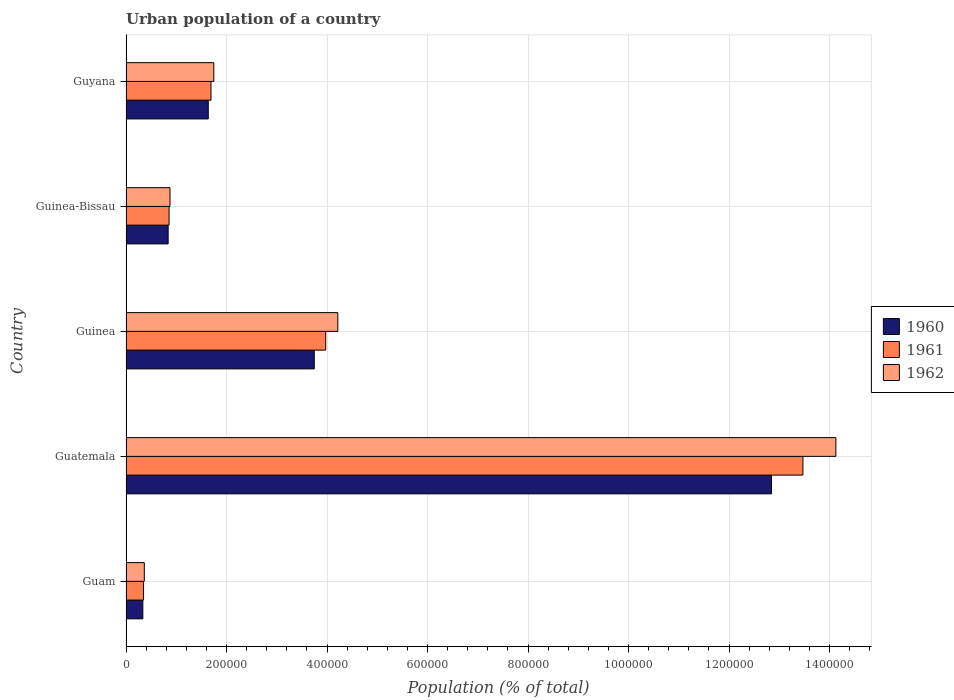How many groups of bars are there?
Offer a terse response. 5. Are the number of bars per tick equal to the number of legend labels?
Give a very brief answer. Yes. How many bars are there on the 3rd tick from the bottom?
Offer a terse response. 3. What is the label of the 5th group of bars from the top?
Ensure brevity in your answer.  Guam. What is the urban population in 1962 in Guam?
Offer a terse response. 3.64e+04. Across all countries, what is the maximum urban population in 1961?
Offer a terse response. 1.35e+06. Across all countries, what is the minimum urban population in 1962?
Keep it short and to the point. 3.64e+04. In which country was the urban population in 1960 maximum?
Provide a succinct answer. Guatemala. In which country was the urban population in 1960 minimum?
Make the answer very short. Guam. What is the total urban population in 1961 in the graph?
Your answer should be very brief. 2.03e+06. What is the difference between the urban population in 1961 in Guatemala and that in Guinea-Bissau?
Ensure brevity in your answer.  1.26e+06. What is the difference between the urban population in 1961 in Guam and the urban population in 1962 in Guinea-Bissau?
Keep it short and to the point. -5.27e+04. What is the average urban population in 1960 per country?
Keep it short and to the point. 3.88e+05. What is the difference between the urban population in 1960 and urban population in 1961 in Guatemala?
Give a very brief answer. -6.25e+04. What is the ratio of the urban population in 1961 in Guatemala to that in Guinea?
Make the answer very short. 3.39. Is the urban population in 1961 in Guam less than that in Guinea-Bissau?
Offer a very short reply. Yes. Is the difference between the urban population in 1960 in Guam and Guinea-Bissau greater than the difference between the urban population in 1961 in Guam and Guinea-Bissau?
Your answer should be very brief. Yes. What is the difference between the highest and the second highest urban population in 1961?
Your answer should be very brief. 9.50e+05. What is the difference between the highest and the lowest urban population in 1960?
Your answer should be very brief. 1.25e+06. In how many countries, is the urban population in 1960 greater than the average urban population in 1960 taken over all countries?
Offer a very short reply. 1. What does the 1st bar from the top in Guam represents?
Provide a succinct answer. 1962. How many bars are there?
Keep it short and to the point. 15. How many countries are there in the graph?
Offer a terse response. 5. What is the difference between two consecutive major ticks on the X-axis?
Make the answer very short. 2.00e+05. Does the graph contain any zero values?
Keep it short and to the point. No. How many legend labels are there?
Make the answer very short. 3. How are the legend labels stacked?
Provide a short and direct response. Vertical. What is the title of the graph?
Provide a short and direct response. Urban population of a country. What is the label or title of the X-axis?
Provide a succinct answer. Population (% of total). What is the Population (% of total) of 1960 in Guam?
Provide a succinct answer. 3.35e+04. What is the Population (% of total) of 1961 in Guam?
Provide a succinct answer. 3.49e+04. What is the Population (% of total) of 1962 in Guam?
Give a very brief answer. 3.64e+04. What is the Population (% of total) of 1960 in Guatemala?
Offer a very short reply. 1.28e+06. What is the Population (% of total) of 1961 in Guatemala?
Your response must be concise. 1.35e+06. What is the Population (% of total) of 1962 in Guatemala?
Offer a terse response. 1.41e+06. What is the Population (% of total) of 1960 in Guinea?
Make the answer very short. 3.75e+05. What is the Population (% of total) of 1961 in Guinea?
Offer a very short reply. 3.97e+05. What is the Population (% of total) in 1962 in Guinea?
Keep it short and to the point. 4.21e+05. What is the Population (% of total) of 1960 in Guinea-Bissau?
Your response must be concise. 8.38e+04. What is the Population (% of total) of 1961 in Guinea-Bissau?
Offer a terse response. 8.57e+04. What is the Population (% of total) in 1962 in Guinea-Bissau?
Your answer should be very brief. 8.75e+04. What is the Population (% of total) of 1960 in Guyana?
Offer a terse response. 1.64e+05. What is the Population (% of total) in 1961 in Guyana?
Make the answer very short. 1.69e+05. What is the Population (% of total) in 1962 in Guyana?
Keep it short and to the point. 1.75e+05. Across all countries, what is the maximum Population (% of total) in 1960?
Ensure brevity in your answer.  1.28e+06. Across all countries, what is the maximum Population (% of total) in 1961?
Ensure brevity in your answer.  1.35e+06. Across all countries, what is the maximum Population (% of total) of 1962?
Your answer should be very brief. 1.41e+06. Across all countries, what is the minimum Population (% of total) of 1960?
Your answer should be compact. 3.35e+04. Across all countries, what is the minimum Population (% of total) in 1961?
Your answer should be very brief. 3.49e+04. Across all countries, what is the minimum Population (% of total) in 1962?
Offer a very short reply. 3.64e+04. What is the total Population (% of total) in 1960 in the graph?
Your answer should be compact. 1.94e+06. What is the total Population (% of total) in 1961 in the graph?
Your response must be concise. 2.03e+06. What is the total Population (% of total) of 1962 in the graph?
Ensure brevity in your answer.  2.13e+06. What is the difference between the Population (% of total) of 1960 in Guam and that in Guatemala?
Make the answer very short. -1.25e+06. What is the difference between the Population (% of total) of 1961 in Guam and that in Guatemala?
Provide a succinct answer. -1.31e+06. What is the difference between the Population (% of total) in 1962 in Guam and that in Guatemala?
Offer a terse response. -1.38e+06. What is the difference between the Population (% of total) of 1960 in Guam and that in Guinea?
Your answer should be very brief. -3.41e+05. What is the difference between the Population (% of total) of 1961 in Guam and that in Guinea?
Make the answer very short. -3.63e+05. What is the difference between the Population (% of total) in 1962 in Guam and that in Guinea?
Give a very brief answer. -3.85e+05. What is the difference between the Population (% of total) in 1960 in Guam and that in Guinea-Bissau?
Offer a very short reply. -5.04e+04. What is the difference between the Population (% of total) in 1961 in Guam and that in Guinea-Bissau?
Provide a short and direct response. -5.08e+04. What is the difference between the Population (% of total) of 1962 in Guam and that in Guinea-Bissau?
Your response must be concise. -5.11e+04. What is the difference between the Population (% of total) in 1960 in Guam and that in Guyana?
Give a very brief answer. -1.30e+05. What is the difference between the Population (% of total) of 1961 in Guam and that in Guyana?
Provide a short and direct response. -1.34e+05. What is the difference between the Population (% of total) in 1962 in Guam and that in Guyana?
Your answer should be compact. -1.38e+05. What is the difference between the Population (% of total) of 1960 in Guatemala and that in Guinea?
Keep it short and to the point. 9.10e+05. What is the difference between the Population (% of total) in 1961 in Guatemala and that in Guinea?
Your response must be concise. 9.50e+05. What is the difference between the Population (% of total) of 1962 in Guatemala and that in Guinea?
Offer a very short reply. 9.91e+05. What is the difference between the Population (% of total) of 1960 in Guatemala and that in Guinea-Bissau?
Offer a very short reply. 1.20e+06. What is the difference between the Population (% of total) of 1961 in Guatemala and that in Guinea-Bissau?
Give a very brief answer. 1.26e+06. What is the difference between the Population (% of total) of 1962 in Guatemala and that in Guinea-Bissau?
Ensure brevity in your answer.  1.33e+06. What is the difference between the Population (% of total) in 1960 in Guatemala and that in Guyana?
Keep it short and to the point. 1.12e+06. What is the difference between the Population (% of total) of 1961 in Guatemala and that in Guyana?
Make the answer very short. 1.18e+06. What is the difference between the Population (% of total) in 1962 in Guatemala and that in Guyana?
Give a very brief answer. 1.24e+06. What is the difference between the Population (% of total) in 1960 in Guinea and that in Guinea-Bissau?
Provide a succinct answer. 2.91e+05. What is the difference between the Population (% of total) in 1961 in Guinea and that in Guinea-Bissau?
Your response must be concise. 3.12e+05. What is the difference between the Population (% of total) in 1962 in Guinea and that in Guinea-Bissau?
Provide a short and direct response. 3.34e+05. What is the difference between the Population (% of total) of 1960 in Guinea and that in Guyana?
Your answer should be compact. 2.11e+05. What is the difference between the Population (% of total) in 1961 in Guinea and that in Guyana?
Make the answer very short. 2.28e+05. What is the difference between the Population (% of total) in 1962 in Guinea and that in Guyana?
Offer a terse response. 2.47e+05. What is the difference between the Population (% of total) in 1960 in Guinea-Bissau and that in Guyana?
Give a very brief answer. -7.98e+04. What is the difference between the Population (% of total) of 1961 in Guinea-Bissau and that in Guyana?
Make the answer very short. -8.34e+04. What is the difference between the Population (% of total) of 1962 in Guinea-Bissau and that in Guyana?
Your response must be concise. -8.72e+04. What is the difference between the Population (% of total) in 1960 in Guam and the Population (% of total) in 1961 in Guatemala?
Offer a terse response. -1.31e+06. What is the difference between the Population (% of total) of 1960 in Guam and the Population (% of total) of 1962 in Guatemala?
Your response must be concise. -1.38e+06. What is the difference between the Population (% of total) of 1961 in Guam and the Population (% of total) of 1962 in Guatemala?
Provide a short and direct response. -1.38e+06. What is the difference between the Population (% of total) in 1960 in Guam and the Population (% of total) in 1961 in Guinea?
Your response must be concise. -3.64e+05. What is the difference between the Population (% of total) of 1960 in Guam and the Population (% of total) of 1962 in Guinea?
Provide a short and direct response. -3.88e+05. What is the difference between the Population (% of total) of 1961 in Guam and the Population (% of total) of 1962 in Guinea?
Ensure brevity in your answer.  -3.87e+05. What is the difference between the Population (% of total) of 1960 in Guam and the Population (% of total) of 1961 in Guinea-Bissau?
Offer a very short reply. -5.22e+04. What is the difference between the Population (% of total) in 1960 in Guam and the Population (% of total) in 1962 in Guinea-Bissau?
Your answer should be compact. -5.41e+04. What is the difference between the Population (% of total) of 1961 in Guam and the Population (% of total) of 1962 in Guinea-Bissau?
Your answer should be compact. -5.27e+04. What is the difference between the Population (% of total) of 1960 in Guam and the Population (% of total) of 1961 in Guyana?
Your answer should be very brief. -1.36e+05. What is the difference between the Population (% of total) in 1960 in Guam and the Population (% of total) in 1962 in Guyana?
Your answer should be very brief. -1.41e+05. What is the difference between the Population (% of total) of 1961 in Guam and the Population (% of total) of 1962 in Guyana?
Provide a short and direct response. -1.40e+05. What is the difference between the Population (% of total) in 1960 in Guatemala and the Population (% of total) in 1961 in Guinea?
Your response must be concise. 8.87e+05. What is the difference between the Population (% of total) in 1960 in Guatemala and the Population (% of total) in 1962 in Guinea?
Ensure brevity in your answer.  8.63e+05. What is the difference between the Population (% of total) in 1961 in Guatemala and the Population (% of total) in 1962 in Guinea?
Give a very brief answer. 9.26e+05. What is the difference between the Population (% of total) in 1960 in Guatemala and the Population (% of total) in 1961 in Guinea-Bissau?
Give a very brief answer. 1.20e+06. What is the difference between the Population (% of total) in 1960 in Guatemala and the Population (% of total) in 1962 in Guinea-Bissau?
Offer a very short reply. 1.20e+06. What is the difference between the Population (% of total) in 1961 in Guatemala and the Population (% of total) in 1962 in Guinea-Bissau?
Provide a succinct answer. 1.26e+06. What is the difference between the Population (% of total) in 1960 in Guatemala and the Population (% of total) in 1961 in Guyana?
Give a very brief answer. 1.12e+06. What is the difference between the Population (% of total) of 1960 in Guatemala and the Population (% of total) of 1962 in Guyana?
Your answer should be compact. 1.11e+06. What is the difference between the Population (% of total) in 1961 in Guatemala and the Population (% of total) in 1962 in Guyana?
Offer a very short reply. 1.17e+06. What is the difference between the Population (% of total) of 1960 in Guinea and the Population (% of total) of 1961 in Guinea-Bissau?
Make the answer very short. 2.89e+05. What is the difference between the Population (% of total) in 1960 in Guinea and the Population (% of total) in 1962 in Guinea-Bissau?
Keep it short and to the point. 2.87e+05. What is the difference between the Population (% of total) of 1961 in Guinea and the Population (% of total) of 1962 in Guinea-Bissau?
Your answer should be compact. 3.10e+05. What is the difference between the Population (% of total) in 1960 in Guinea and the Population (% of total) in 1961 in Guyana?
Offer a very short reply. 2.06e+05. What is the difference between the Population (% of total) in 1960 in Guinea and the Population (% of total) in 1962 in Guyana?
Give a very brief answer. 2.00e+05. What is the difference between the Population (% of total) in 1961 in Guinea and the Population (% of total) in 1962 in Guyana?
Provide a succinct answer. 2.23e+05. What is the difference between the Population (% of total) in 1960 in Guinea-Bissau and the Population (% of total) in 1961 in Guyana?
Offer a terse response. -8.52e+04. What is the difference between the Population (% of total) in 1960 in Guinea-Bissau and the Population (% of total) in 1962 in Guyana?
Offer a very short reply. -9.09e+04. What is the difference between the Population (% of total) of 1961 in Guinea-Bissau and the Population (% of total) of 1962 in Guyana?
Keep it short and to the point. -8.90e+04. What is the average Population (% of total) in 1960 per country?
Keep it short and to the point. 3.88e+05. What is the average Population (% of total) of 1961 per country?
Provide a short and direct response. 4.07e+05. What is the average Population (% of total) in 1962 per country?
Your answer should be very brief. 4.27e+05. What is the difference between the Population (% of total) of 1960 and Population (% of total) of 1961 in Guam?
Make the answer very short. -1405. What is the difference between the Population (% of total) in 1960 and Population (% of total) in 1962 in Guam?
Ensure brevity in your answer.  -2945. What is the difference between the Population (% of total) in 1961 and Population (% of total) in 1962 in Guam?
Ensure brevity in your answer.  -1540. What is the difference between the Population (% of total) of 1960 and Population (% of total) of 1961 in Guatemala?
Give a very brief answer. -6.25e+04. What is the difference between the Population (% of total) in 1960 and Population (% of total) in 1962 in Guatemala?
Provide a succinct answer. -1.28e+05. What is the difference between the Population (% of total) of 1961 and Population (% of total) of 1962 in Guatemala?
Your answer should be very brief. -6.56e+04. What is the difference between the Population (% of total) in 1960 and Population (% of total) in 1961 in Guinea?
Give a very brief answer. -2.28e+04. What is the difference between the Population (% of total) of 1960 and Population (% of total) of 1962 in Guinea?
Offer a very short reply. -4.68e+04. What is the difference between the Population (% of total) of 1961 and Population (% of total) of 1962 in Guinea?
Provide a short and direct response. -2.40e+04. What is the difference between the Population (% of total) of 1960 and Population (% of total) of 1961 in Guinea-Bissau?
Provide a short and direct response. -1870. What is the difference between the Population (% of total) in 1960 and Population (% of total) in 1962 in Guinea-Bissau?
Provide a succinct answer. -3704. What is the difference between the Population (% of total) of 1961 and Population (% of total) of 1962 in Guinea-Bissau?
Keep it short and to the point. -1834. What is the difference between the Population (% of total) in 1960 and Population (% of total) in 1961 in Guyana?
Your answer should be very brief. -5400. What is the difference between the Population (% of total) in 1960 and Population (% of total) in 1962 in Guyana?
Make the answer very short. -1.10e+04. What is the difference between the Population (% of total) in 1961 and Population (% of total) in 1962 in Guyana?
Provide a succinct answer. -5622. What is the ratio of the Population (% of total) in 1960 in Guam to that in Guatemala?
Make the answer very short. 0.03. What is the ratio of the Population (% of total) in 1961 in Guam to that in Guatemala?
Offer a very short reply. 0.03. What is the ratio of the Population (% of total) in 1962 in Guam to that in Guatemala?
Offer a terse response. 0.03. What is the ratio of the Population (% of total) in 1960 in Guam to that in Guinea?
Offer a very short reply. 0.09. What is the ratio of the Population (% of total) of 1961 in Guam to that in Guinea?
Give a very brief answer. 0.09. What is the ratio of the Population (% of total) in 1962 in Guam to that in Guinea?
Make the answer very short. 0.09. What is the ratio of the Population (% of total) in 1960 in Guam to that in Guinea-Bissau?
Provide a short and direct response. 0.4. What is the ratio of the Population (% of total) of 1961 in Guam to that in Guinea-Bissau?
Offer a terse response. 0.41. What is the ratio of the Population (% of total) in 1962 in Guam to that in Guinea-Bissau?
Your answer should be very brief. 0.42. What is the ratio of the Population (% of total) of 1960 in Guam to that in Guyana?
Provide a succinct answer. 0.2. What is the ratio of the Population (% of total) of 1961 in Guam to that in Guyana?
Offer a very short reply. 0.21. What is the ratio of the Population (% of total) in 1962 in Guam to that in Guyana?
Provide a short and direct response. 0.21. What is the ratio of the Population (% of total) in 1960 in Guatemala to that in Guinea?
Offer a terse response. 3.43. What is the ratio of the Population (% of total) of 1961 in Guatemala to that in Guinea?
Make the answer very short. 3.39. What is the ratio of the Population (% of total) of 1962 in Guatemala to that in Guinea?
Ensure brevity in your answer.  3.35. What is the ratio of the Population (% of total) of 1960 in Guatemala to that in Guinea-Bissau?
Offer a terse response. 15.32. What is the ratio of the Population (% of total) of 1961 in Guatemala to that in Guinea-Bissau?
Provide a succinct answer. 15.72. What is the ratio of the Population (% of total) of 1962 in Guatemala to that in Guinea-Bissau?
Your answer should be compact. 16.14. What is the ratio of the Population (% of total) in 1960 in Guatemala to that in Guyana?
Your answer should be compact. 7.85. What is the ratio of the Population (% of total) in 1961 in Guatemala to that in Guyana?
Offer a terse response. 7.97. What is the ratio of the Population (% of total) in 1962 in Guatemala to that in Guyana?
Keep it short and to the point. 8.09. What is the ratio of the Population (% of total) in 1960 in Guinea to that in Guinea-Bissau?
Your answer should be very brief. 4.47. What is the ratio of the Population (% of total) in 1961 in Guinea to that in Guinea-Bissau?
Your response must be concise. 4.64. What is the ratio of the Population (% of total) in 1962 in Guinea to that in Guinea-Bissau?
Your response must be concise. 4.81. What is the ratio of the Population (% of total) in 1960 in Guinea to that in Guyana?
Your answer should be very brief. 2.29. What is the ratio of the Population (% of total) of 1961 in Guinea to that in Guyana?
Provide a short and direct response. 2.35. What is the ratio of the Population (% of total) of 1962 in Guinea to that in Guyana?
Keep it short and to the point. 2.41. What is the ratio of the Population (% of total) of 1960 in Guinea-Bissau to that in Guyana?
Keep it short and to the point. 0.51. What is the ratio of the Population (% of total) in 1961 in Guinea-Bissau to that in Guyana?
Ensure brevity in your answer.  0.51. What is the ratio of the Population (% of total) in 1962 in Guinea-Bissau to that in Guyana?
Ensure brevity in your answer.  0.5. What is the difference between the highest and the second highest Population (% of total) in 1960?
Give a very brief answer. 9.10e+05. What is the difference between the highest and the second highest Population (% of total) in 1961?
Offer a very short reply. 9.50e+05. What is the difference between the highest and the second highest Population (% of total) of 1962?
Make the answer very short. 9.91e+05. What is the difference between the highest and the lowest Population (% of total) in 1960?
Provide a succinct answer. 1.25e+06. What is the difference between the highest and the lowest Population (% of total) of 1961?
Provide a short and direct response. 1.31e+06. What is the difference between the highest and the lowest Population (% of total) of 1962?
Your answer should be compact. 1.38e+06. 